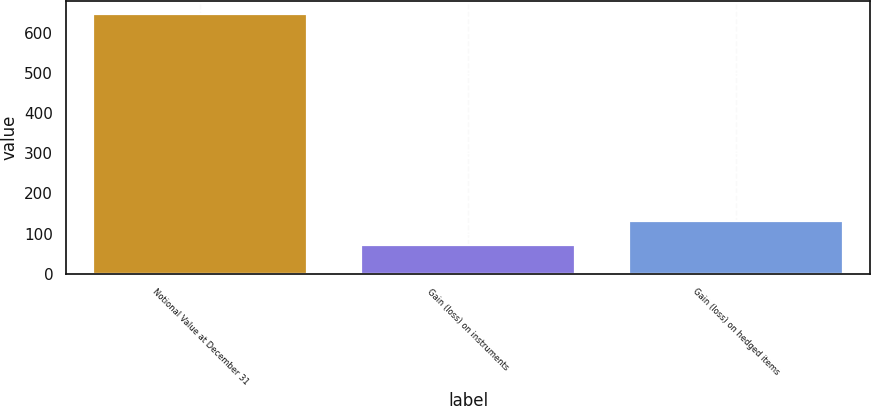<chart> <loc_0><loc_0><loc_500><loc_500><bar_chart><fcel>Notional Value at December 31<fcel>Gain (loss) on instruments<fcel>Gain (loss) on hedged items<nl><fcel>645<fcel>73<fcel>130.2<nl></chart> 